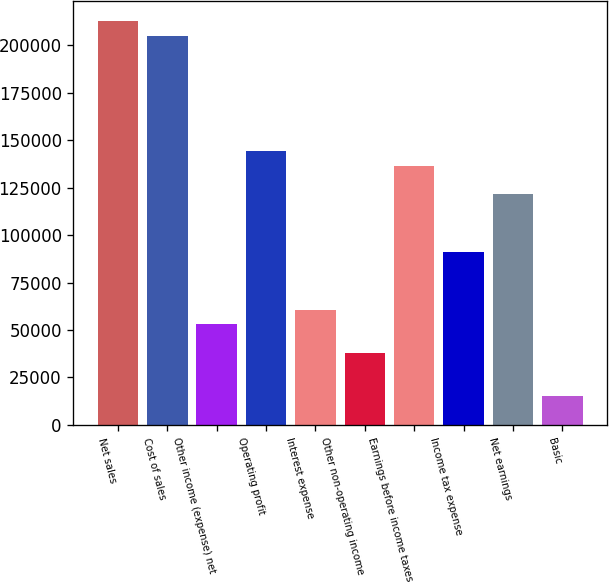Convert chart. <chart><loc_0><loc_0><loc_500><loc_500><bar_chart><fcel>Net sales<fcel>Cost of sales<fcel>Other income (expense) net<fcel>Operating profit<fcel>Interest expense<fcel>Other non-operating income<fcel>Earnings before income taxes<fcel>Income tax expense<fcel>Net earnings<fcel>Basic<nl><fcel>212532<fcel>204941<fcel>53133.9<fcel>144218<fcel>60724.2<fcel>37953.1<fcel>136628<fcel>91085.7<fcel>121447<fcel>15182<nl></chart> 